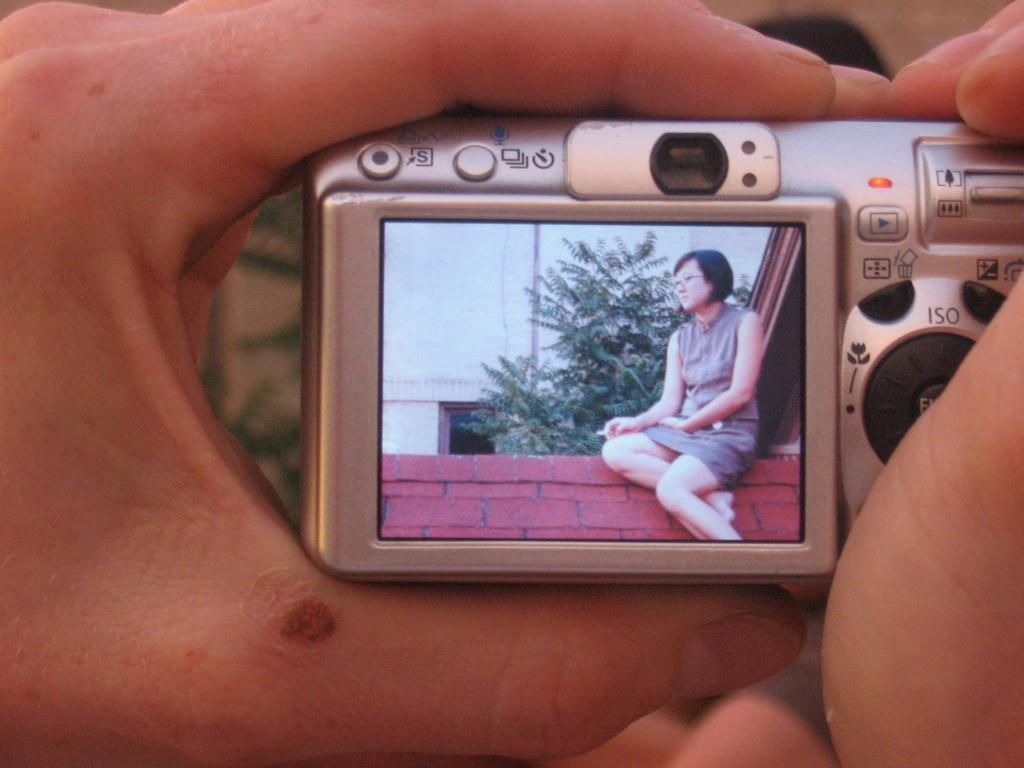<image>
Share a concise interpretation of the image provided. The ISO on this camera is to the right of the screen. 